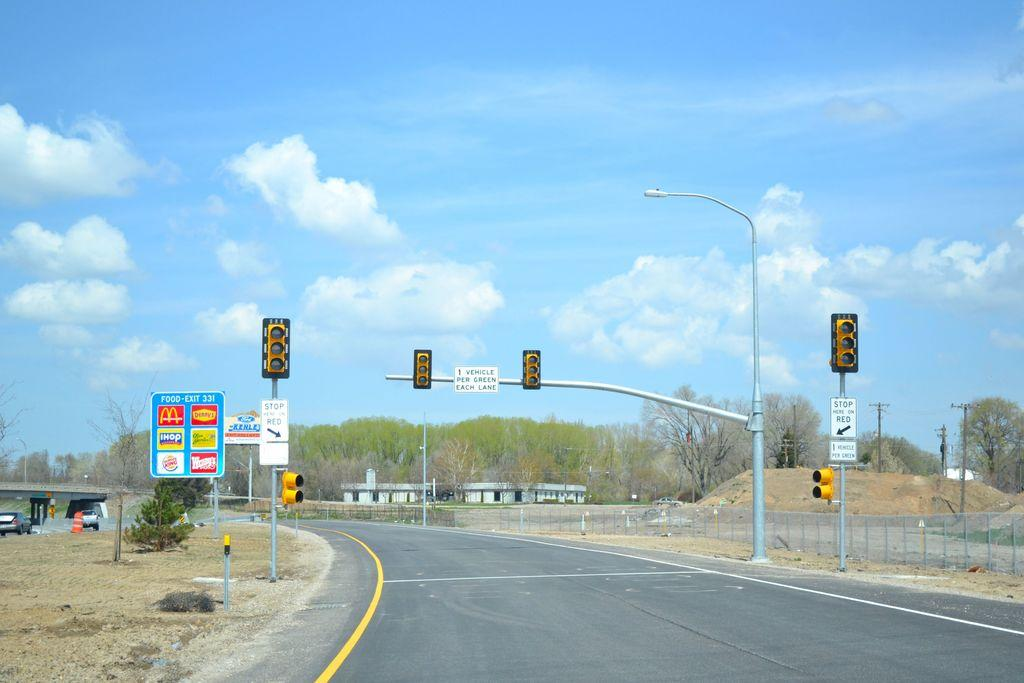<image>
Present a compact description of the photo's key features. a deserted street and light has sign reading Vehicle Per Green 